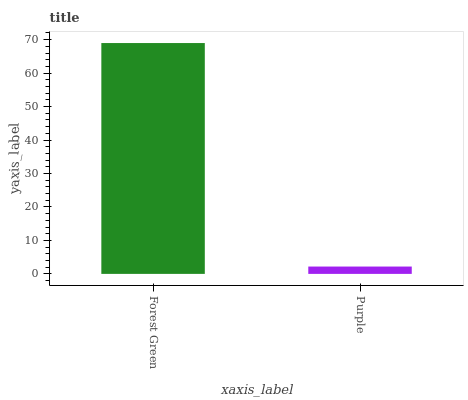Is Purple the minimum?
Answer yes or no. Yes. Is Forest Green the maximum?
Answer yes or no. Yes. Is Purple the maximum?
Answer yes or no. No. Is Forest Green greater than Purple?
Answer yes or no. Yes. Is Purple less than Forest Green?
Answer yes or no. Yes. Is Purple greater than Forest Green?
Answer yes or no. No. Is Forest Green less than Purple?
Answer yes or no. No. Is Forest Green the high median?
Answer yes or no. Yes. Is Purple the low median?
Answer yes or no. Yes. Is Purple the high median?
Answer yes or no. No. Is Forest Green the low median?
Answer yes or no. No. 